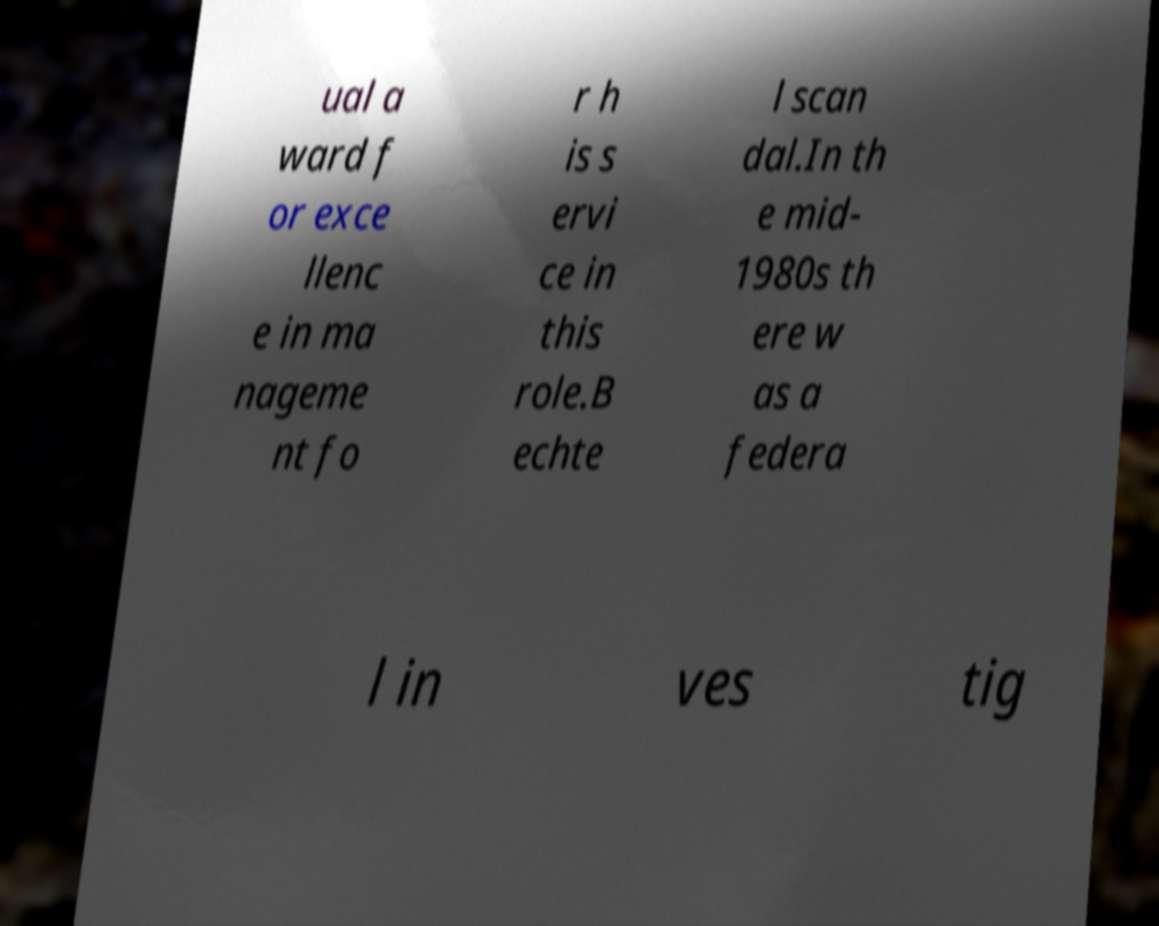Can you read and provide the text displayed in the image?This photo seems to have some interesting text. Can you extract and type it out for me? ual a ward f or exce llenc e in ma nageme nt fo r h is s ervi ce in this role.B echte l scan dal.In th e mid- 1980s th ere w as a federa l in ves tig 